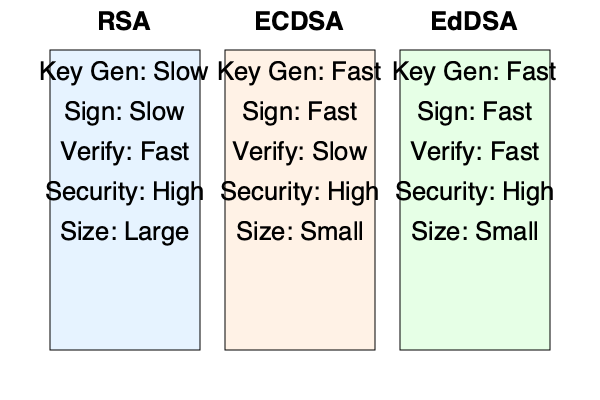Based on the visual comparison of RSA, ECDSA, and EdDSA digital signature algorithms, which algorithm would be most suitable for a resource-constrained IoT device that requires frequent signature generation and verification, while maintaining a high level of security? To determine the most suitable algorithm for a resource-constrained IoT device, we need to consider several factors:

1. Key Generation Speed:
   - RSA: Slow
   - ECDSA: Fast
   - EdDSA: Fast

2. Signing Speed:
   - RSA: Slow
   - ECDSA: Fast
   - EdDSA: Fast

3. Verification Speed:
   - RSA: Fast
   - ECDSA: Slow
   - EdDSA: Fast

4. Security Level:
   - All three algorithms provide high security

5. Key and Signature Size:
   - RSA: Large
   - ECDSA: Small
   - EdDSA: Small

For a resource-constrained IoT device:
- Fast key generation is important to minimize computational overhead.
- Fast signing is crucial for frequent signature generation.
- Fast verification is beneficial for quick processing of received signatures.
- Small key and signature sizes are advantageous for limited storage and bandwidth.

Considering these factors:
- RSA is not suitable due to slow key generation, slow signing, and large size.
- ECDSA is better than RSA but has slow verification.
- EdDSA offers fast performance in all operations (key generation, signing, and verification) and has small key and signature sizes.

Therefore, EdDSA (Edwards-curve Digital Signature Algorithm) is the most suitable choice for a resource-constrained IoT device requiring frequent signature generation and verification while maintaining high security.
Answer: EdDSA 